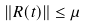<formula> <loc_0><loc_0><loc_500><loc_500>\| R ( t ) \| \leq \mu</formula> 